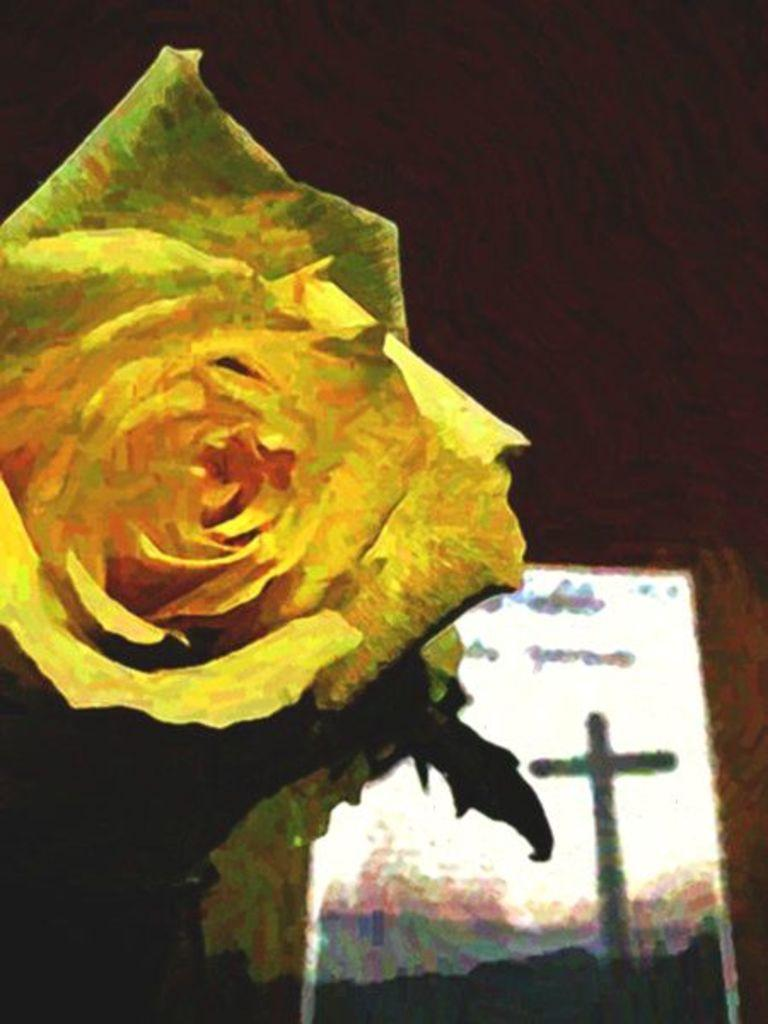What is the main subject of the image? The main subject of the image is a painting. What is depicted in the painting? The painting contains a flower and a wall. Can you describe the unspecified object in the painting? Unfortunately, the facts provided do not give any details about the unspecified object in the painting. How many units are present in the cemetery depicted in the painting? There is no cemetery depicted in the painting; it contains a flower and a wall. What type of zebra can be seen interacting with the flower in the painting? There is no zebra present in the painting; it contains a flower and a wall. 